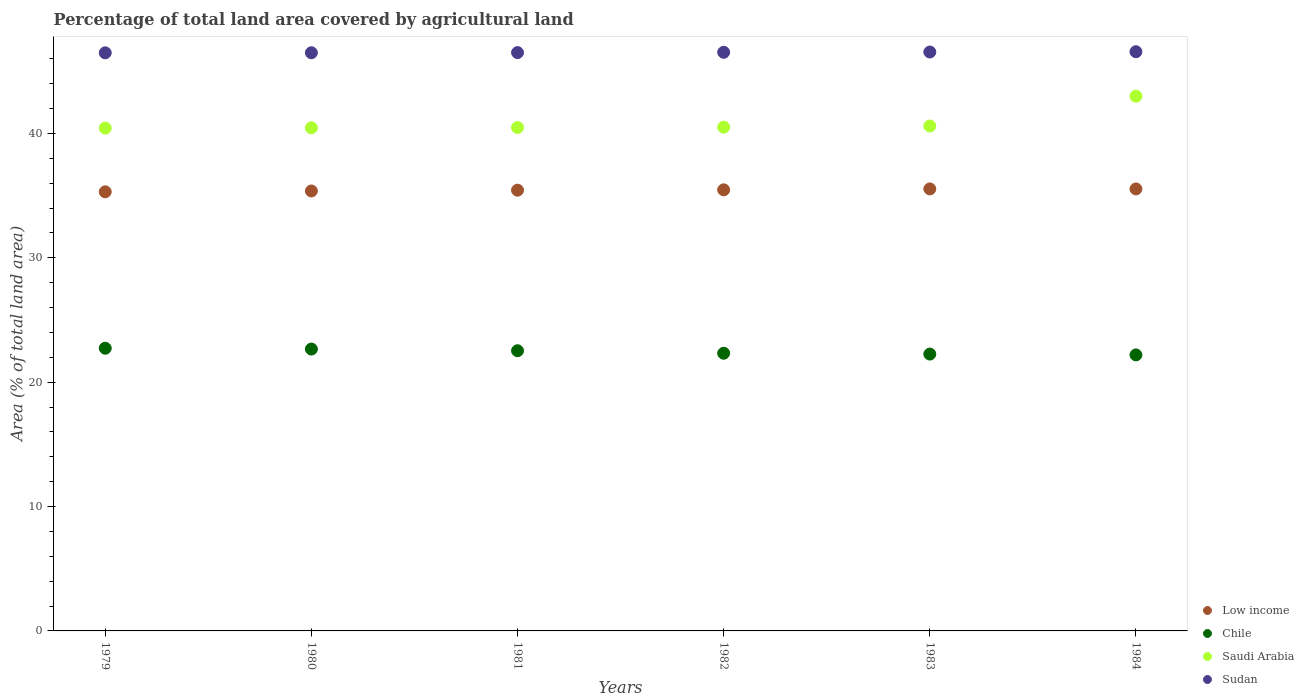How many different coloured dotlines are there?
Provide a succinct answer. 4. What is the percentage of agricultural land in Sudan in 1984?
Your answer should be compact. 46.57. Across all years, what is the maximum percentage of agricultural land in Chile?
Your response must be concise. 22.73. Across all years, what is the minimum percentage of agricultural land in Chile?
Your response must be concise. 22.19. In which year was the percentage of agricultural land in Saudi Arabia minimum?
Your answer should be very brief. 1979. What is the total percentage of agricultural land in Sudan in the graph?
Your answer should be very brief. 279.1. What is the difference between the percentage of agricultural land in Chile in 1980 and that in 1984?
Give a very brief answer. 0.47. What is the difference between the percentage of agricultural land in Sudan in 1979 and the percentage of agricultural land in Saudi Arabia in 1980?
Provide a succinct answer. 6.03. What is the average percentage of agricultural land in Saudi Arabia per year?
Offer a very short reply. 40.91. In the year 1983, what is the difference between the percentage of agricultural land in Chile and percentage of agricultural land in Low income?
Your response must be concise. -13.28. In how many years, is the percentage of agricultural land in Saudi Arabia greater than 42 %?
Give a very brief answer. 1. What is the ratio of the percentage of agricultural land in Low income in 1981 to that in 1982?
Provide a succinct answer. 1. Is the percentage of agricultural land in Saudi Arabia in 1982 less than that in 1984?
Make the answer very short. Yes. Is the difference between the percentage of agricultural land in Chile in 1983 and 1984 greater than the difference between the percentage of agricultural land in Low income in 1983 and 1984?
Your response must be concise. Yes. What is the difference between the highest and the second highest percentage of agricultural land in Saudi Arabia?
Your answer should be very brief. 2.4. What is the difference between the highest and the lowest percentage of agricultural land in Chile?
Make the answer very short. 0.54. Is it the case that in every year, the sum of the percentage of agricultural land in Low income and percentage of agricultural land in Saudi Arabia  is greater than the percentage of agricultural land in Sudan?
Keep it short and to the point. Yes. Does the percentage of agricultural land in Sudan monotonically increase over the years?
Make the answer very short. Yes. Is the percentage of agricultural land in Chile strictly greater than the percentage of agricultural land in Sudan over the years?
Offer a very short reply. No. Is the percentage of agricultural land in Low income strictly less than the percentage of agricultural land in Saudi Arabia over the years?
Make the answer very short. Yes. How many years are there in the graph?
Give a very brief answer. 6. Does the graph contain grids?
Provide a short and direct response. No. How are the legend labels stacked?
Give a very brief answer. Vertical. What is the title of the graph?
Give a very brief answer. Percentage of total land area covered by agricultural land. What is the label or title of the Y-axis?
Offer a terse response. Area (% of total land area). What is the Area (% of total land area) of Low income in 1979?
Provide a short and direct response. 35.31. What is the Area (% of total land area) of Chile in 1979?
Offer a terse response. 22.73. What is the Area (% of total land area) of Saudi Arabia in 1979?
Provide a short and direct response. 40.43. What is the Area (% of total land area) in Sudan in 1979?
Your response must be concise. 46.48. What is the Area (% of total land area) in Low income in 1980?
Make the answer very short. 35.37. What is the Area (% of total land area) of Chile in 1980?
Your response must be concise. 22.66. What is the Area (% of total land area) in Saudi Arabia in 1980?
Offer a terse response. 40.45. What is the Area (% of total land area) in Sudan in 1980?
Give a very brief answer. 46.49. What is the Area (% of total land area) in Low income in 1981?
Provide a succinct answer. 35.44. What is the Area (% of total land area) in Chile in 1981?
Keep it short and to the point. 22.53. What is the Area (% of total land area) in Saudi Arabia in 1981?
Your answer should be very brief. 40.48. What is the Area (% of total land area) in Sudan in 1981?
Your response must be concise. 46.5. What is the Area (% of total land area) of Low income in 1982?
Your answer should be compact. 35.46. What is the Area (% of total land area) of Chile in 1982?
Make the answer very short. 22.33. What is the Area (% of total land area) of Saudi Arabia in 1982?
Provide a short and direct response. 40.5. What is the Area (% of total land area) of Sudan in 1982?
Give a very brief answer. 46.52. What is the Area (% of total land area) of Low income in 1983?
Ensure brevity in your answer.  35.54. What is the Area (% of total land area) in Chile in 1983?
Provide a succinct answer. 22.26. What is the Area (% of total land area) of Saudi Arabia in 1983?
Your answer should be compact. 40.6. What is the Area (% of total land area) in Sudan in 1983?
Provide a short and direct response. 46.54. What is the Area (% of total land area) in Low income in 1984?
Make the answer very short. 35.54. What is the Area (% of total land area) of Chile in 1984?
Offer a very short reply. 22.19. What is the Area (% of total land area) in Saudi Arabia in 1984?
Provide a succinct answer. 42.99. What is the Area (% of total land area) in Sudan in 1984?
Make the answer very short. 46.57. Across all years, what is the maximum Area (% of total land area) of Low income?
Provide a short and direct response. 35.54. Across all years, what is the maximum Area (% of total land area) in Chile?
Make the answer very short. 22.73. Across all years, what is the maximum Area (% of total land area) of Saudi Arabia?
Give a very brief answer. 42.99. Across all years, what is the maximum Area (% of total land area) of Sudan?
Your answer should be compact. 46.57. Across all years, what is the minimum Area (% of total land area) in Low income?
Provide a short and direct response. 35.31. Across all years, what is the minimum Area (% of total land area) in Chile?
Provide a succinct answer. 22.19. Across all years, what is the minimum Area (% of total land area) of Saudi Arabia?
Provide a short and direct response. 40.43. Across all years, what is the minimum Area (% of total land area) in Sudan?
Offer a terse response. 46.48. What is the total Area (% of total land area) of Low income in the graph?
Your answer should be compact. 212.65. What is the total Area (% of total land area) of Chile in the graph?
Keep it short and to the point. 134.69. What is the total Area (% of total land area) in Saudi Arabia in the graph?
Offer a terse response. 245.45. What is the total Area (% of total land area) of Sudan in the graph?
Make the answer very short. 279.1. What is the difference between the Area (% of total land area) of Low income in 1979 and that in 1980?
Your answer should be very brief. -0.07. What is the difference between the Area (% of total land area) in Chile in 1979 and that in 1980?
Give a very brief answer. 0.07. What is the difference between the Area (% of total land area) in Saudi Arabia in 1979 and that in 1980?
Keep it short and to the point. -0.02. What is the difference between the Area (% of total land area) in Sudan in 1979 and that in 1980?
Make the answer very short. -0.01. What is the difference between the Area (% of total land area) of Low income in 1979 and that in 1981?
Provide a succinct answer. -0.13. What is the difference between the Area (% of total land area) of Chile in 1979 and that in 1981?
Offer a very short reply. 0.2. What is the difference between the Area (% of total land area) of Saudi Arabia in 1979 and that in 1981?
Provide a short and direct response. -0.05. What is the difference between the Area (% of total land area) of Sudan in 1979 and that in 1981?
Provide a short and direct response. -0.02. What is the difference between the Area (% of total land area) of Low income in 1979 and that in 1982?
Make the answer very short. -0.16. What is the difference between the Area (% of total land area) in Chile in 1979 and that in 1982?
Give a very brief answer. 0.4. What is the difference between the Area (% of total land area) of Saudi Arabia in 1979 and that in 1982?
Ensure brevity in your answer.  -0.07. What is the difference between the Area (% of total land area) of Sudan in 1979 and that in 1982?
Ensure brevity in your answer.  -0.04. What is the difference between the Area (% of total land area) of Low income in 1979 and that in 1983?
Offer a terse response. -0.23. What is the difference between the Area (% of total land area) in Chile in 1979 and that in 1983?
Provide a short and direct response. 0.47. What is the difference between the Area (% of total land area) in Saudi Arabia in 1979 and that in 1983?
Provide a succinct answer. -0.17. What is the difference between the Area (% of total land area) of Sudan in 1979 and that in 1983?
Offer a very short reply. -0.07. What is the difference between the Area (% of total land area) in Low income in 1979 and that in 1984?
Ensure brevity in your answer.  -0.23. What is the difference between the Area (% of total land area) of Chile in 1979 and that in 1984?
Ensure brevity in your answer.  0.54. What is the difference between the Area (% of total land area) of Saudi Arabia in 1979 and that in 1984?
Give a very brief answer. -2.56. What is the difference between the Area (% of total land area) of Sudan in 1979 and that in 1984?
Give a very brief answer. -0.09. What is the difference between the Area (% of total land area) of Low income in 1980 and that in 1981?
Offer a very short reply. -0.06. What is the difference between the Area (% of total land area) in Chile in 1980 and that in 1981?
Your answer should be very brief. 0.13. What is the difference between the Area (% of total land area) in Saudi Arabia in 1980 and that in 1981?
Your response must be concise. -0.02. What is the difference between the Area (% of total land area) of Sudan in 1980 and that in 1981?
Give a very brief answer. -0.01. What is the difference between the Area (% of total land area) of Low income in 1980 and that in 1982?
Keep it short and to the point. -0.09. What is the difference between the Area (% of total land area) in Chile in 1980 and that in 1982?
Your answer should be compact. 0.34. What is the difference between the Area (% of total land area) of Saudi Arabia in 1980 and that in 1982?
Keep it short and to the point. -0.05. What is the difference between the Area (% of total land area) in Sudan in 1980 and that in 1982?
Give a very brief answer. -0.04. What is the difference between the Area (% of total land area) of Low income in 1980 and that in 1983?
Your response must be concise. -0.17. What is the difference between the Area (% of total land area) in Chile in 1980 and that in 1983?
Offer a very short reply. 0.4. What is the difference between the Area (% of total land area) of Saudi Arabia in 1980 and that in 1983?
Your answer should be compact. -0.14. What is the difference between the Area (% of total land area) in Sudan in 1980 and that in 1983?
Provide a short and direct response. -0.06. What is the difference between the Area (% of total land area) of Low income in 1980 and that in 1984?
Keep it short and to the point. -0.16. What is the difference between the Area (% of total land area) in Chile in 1980 and that in 1984?
Make the answer very short. 0.47. What is the difference between the Area (% of total land area) of Saudi Arabia in 1980 and that in 1984?
Keep it short and to the point. -2.54. What is the difference between the Area (% of total land area) in Sudan in 1980 and that in 1984?
Offer a terse response. -0.08. What is the difference between the Area (% of total land area) of Low income in 1981 and that in 1982?
Make the answer very short. -0.03. What is the difference between the Area (% of total land area) of Chile in 1981 and that in 1982?
Give a very brief answer. 0.2. What is the difference between the Area (% of total land area) of Saudi Arabia in 1981 and that in 1982?
Your response must be concise. -0.03. What is the difference between the Area (% of total land area) of Sudan in 1981 and that in 1982?
Provide a short and direct response. -0.03. What is the difference between the Area (% of total land area) in Low income in 1981 and that in 1983?
Ensure brevity in your answer.  -0.1. What is the difference between the Area (% of total land area) in Chile in 1981 and that in 1983?
Keep it short and to the point. 0.27. What is the difference between the Area (% of total land area) in Saudi Arabia in 1981 and that in 1983?
Provide a succinct answer. -0.12. What is the difference between the Area (% of total land area) in Sudan in 1981 and that in 1983?
Keep it short and to the point. -0.05. What is the difference between the Area (% of total land area) of Low income in 1981 and that in 1984?
Provide a succinct answer. -0.1. What is the difference between the Area (% of total land area) in Chile in 1981 and that in 1984?
Your answer should be very brief. 0.34. What is the difference between the Area (% of total land area) of Saudi Arabia in 1981 and that in 1984?
Your answer should be compact. -2.52. What is the difference between the Area (% of total land area) in Sudan in 1981 and that in 1984?
Keep it short and to the point. -0.07. What is the difference between the Area (% of total land area) in Low income in 1982 and that in 1983?
Offer a very short reply. -0.07. What is the difference between the Area (% of total land area) of Chile in 1982 and that in 1983?
Your answer should be very brief. 0.07. What is the difference between the Area (% of total land area) in Saudi Arabia in 1982 and that in 1983?
Ensure brevity in your answer.  -0.09. What is the difference between the Area (% of total land area) in Sudan in 1982 and that in 1983?
Make the answer very short. -0.02. What is the difference between the Area (% of total land area) of Low income in 1982 and that in 1984?
Offer a terse response. -0.07. What is the difference between the Area (% of total land area) of Chile in 1982 and that in 1984?
Your response must be concise. 0.13. What is the difference between the Area (% of total land area) in Saudi Arabia in 1982 and that in 1984?
Your answer should be compact. -2.49. What is the difference between the Area (% of total land area) of Sudan in 1982 and that in 1984?
Your response must be concise. -0.04. What is the difference between the Area (% of total land area) in Low income in 1983 and that in 1984?
Your answer should be compact. 0. What is the difference between the Area (% of total land area) of Chile in 1983 and that in 1984?
Offer a terse response. 0.07. What is the difference between the Area (% of total land area) in Saudi Arabia in 1983 and that in 1984?
Your answer should be very brief. -2.4. What is the difference between the Area (% of total land area) in Sudan in 1983 and that in 1984?
Offer a very short reply. -0.02. What is the difference between the Area (% of total land area) of Low income in 1979 and the Area (% of total land area) of Chile in 1980?
Ensure brevity in your answer.  12.64. What is the difference between the Area (% of total land area) of Low income in 1979 and the Area (% of total land area) of Saudi Arabia in 1980?
Your response must be concise. -5.15. What is the difference between the Area (% of total land area) in Low income in 1979 and the Area (% of total land area) in Sudan in 1980?
Provide a short and direct response. -11.18. What is the difference between the Area (% of total land area) in Chile in 1979 and the Area (% of total land area) in Saudi Arabia in 1980?
Keep it short and to the point. -17.72. What is the difference between the Area (% of total land area) in Chile in 1979 and the Area (% of total land area) in Sudan in 1980?
Offer a terse response. -23.76. What is the difference between the Area (% of total land area) in Saudi Arabia in 1979 and the Area (% of total land area) in Sudan in 1980?
Give a very brief answer. -6.06. What is the difference between the Area (% of total land area) of Low income in 1979 and the Area (% of total land area) of Chile in 1981?
Your answer should be very brief. 12.78. What is the difference between the Area (% of total land area) in Low income in 1979 and the Area (% of total land area) in Saudi Arabia in 1981?
Provide a succinct answer. -5.17. What is the difference between the Area (% of total land area) of Low income in 1979 and the Area (% of total land area) of Sudan in 1981?
Offer a terse response. -11.19. What is the difference between the Area (% of total land area) in Chile in 1979 and the Area (% of total land area) in Saudi Arabia in 1981?
Your answer should be compact. -17.75. What is the difference between the Area (% of total land area) of Chile in 1979 and the Area (% of total land area) of Sudan in 1981?
Your response must be concise. -23.77. What is the difference between the Area (% of total land area) of Saudi Arabia in 1979 and the Area (% of total land area) of Sudan in 1981?
Your answer should be compact. -6.07. What is the difference between the Area (% of total land area) in Low income in 1979 and the Area (% of total land area) in Chile in 1982?
Ensure brevity in your answer.  12.98. What is the difference between the Area (% of total land area) of Low income in 1979 and the Area (% of total land area) of Saudi Arabia in 1982?
Your answer should be very brief. -5.2. What is the difference between the Area (% of total land area) in Low income in 1979 and the Area (% of total land area) in Sudan in 1982?
Offer a very short reply. -11.22. What is the difference between the Area (% of total land area) of Chile in 1979 and the Area (% of total land area) of Saudi Arabia in 1982?
Your answer should be very brief. -17.77. What is the difference between the Area (% of total land area) of Chile in 1979 and the Area (% of total land area) of Sudan in 1982?
Offer a terse response. -23.79. What is the difference between the Area (% of total land area) of Saudi Arabia in 1979 and the Area (% of total land area) of Sudan in 1982?
Your answer should be compact. -6.09. What is the difference between the Area (% of total land area) of Low income in 1979 and the Area (% of total land area) of Chile in 1983?
Provide a succinct answer. 13.05. What is the difference between the Area (% of total land area) in Low income in 1979 and the Area (% of total land area) in Saudi Arabia in 1983?
Your answer should be compact. -5.29. What is the difference between the Area (% of total land area) of Low income in 1979 and the Area (% of total land area) of Sudan in 1983?
Your answer should be very brief. -11.24. What is the difference between the Area (% of total land area) in Chile in 1979 and the Area (% of total land area) in Saudi Arabia in 1983?
Provide a short and direct response. -17.87. What is the difference between the Area (% of total land area) in Chile in 1979 and the Area (% of total land area) in Sudan in 1983?
Provide a succinct answer. -23.82. What is the difference between the Area (% of total land area) in Saudi Arabia in 1979 and the Area (% of total land area) in Sudan in 1983?
Keep it short and to the point. -6.12. What is the difference between the Area (% of total land area) in Low income in 1979 and the Area (% of total land area) in Chile in 1984?
Offer a terse response. 13.11. What is the difference between the Area (% of total land area) of Low income in 1979 and the Area (% of total land area) of Saudi Arabia in 1984?
Your answer should be compact. -7.69. What is the difference between the Area (% of total land area) in Low income in 1979 and the Area (% of total land area) in Sudan in 1984?
Keep it short and to the point. -11.26. What is the difference between the Area (% of total land area) in Chile in 1979 and the Area (% of total land area) in Saudi Arabia in 1984?
Ensure brevity in your answer.  -20.26. What is the difference between the Area (% of total land area) in Chile in 1979 and the Area (% of total land area) in Sudan in 1984?
Make the answer very short. -23.84. What is the difference between the Area (% of total land area) of Saudi Arabia in 1979 and the Area (% of total land area) of Sudan in 1984?
Make the answer very short. -6.14. What is the difference between the Area (% of total land area) in Low income in 1980 and the Area (% of total land area) in Chile in 1981?
Provide a succinct answer. 12.85. What is the difference between the Area (% of total land area) in Low income in 1980 and the Area (% of total land area) in Saudi Arabia in 1981?
Your answer should be compact. -5.1. What is the difference between the Area (% of total land area) in Low income in 1980 and the Area (% of total land area) in Sudan in 1981?
Offer a very short reply. -11.13. What is the difference between the Area (% of total land area) in Chile in 1980 and the Area (% of total land area) in Saudi Arabia in 1981?
Your response must be concise. -17.81. What is the difference between the Area (% of total land area) in Chile in 1980 and the Area (% of total land area) in Sudan in 1981?
Keep it short and to the point. -23.84. What is the difference between the Area (% of total land area) in Saudi Arabia in 1980 and the Area (% of total land area) in Sudan in 1981?
Keep it short and to the point. -6.04. What is the difference between the Area (% of total land area) in Low income in 1980 and the Area (% of total land area) in Chile in 1982?
Provide a short and direct response. 13.05. What is the difference between the Area (% of total land area) in Low income in 1980 and the Area (% of total land area) in Saudi Arabia in 1982?
Provide a short and direct response. -5.13. What is the difference between the Area (% of total land area) of Low income in 1980 and the Area (% of total land area) of Sudan in 1982?
Provide a succinct answer. -11.15. What is the difference between the Area (% of total land area) of Chile in 1980 and the Area (% of total land area) of Saudi Arabia in 1982?
Offer a terse response. -17.84. What is the difference between the Area (% of total land area) in Chile in 1980 and the Area (% of total land area) in Sudan in 1982?
Your answer should be very brief. -23.86. What is the difference between the Area (% of total land area) in Saudi Arabia in 1980 and the Area (% of total land area) in Sudan in 1982?
Give a very brief answer. -6.07. What is the difference between the Area (% of total land area) of Low income in 1980 and the Area (% of total land area) of Chile in 1983?
Provide a short and direct response. 13.11. What is the difference between the Area (% of total land area) of Low income in 1980 and the Area (% of total land area) of Saudi Arabia in 1983?
Provide a succinct answer. -5.22. What is the difference between the Area (% of total land area) in Low income in 1980 and the Area (% of total land area) in Sudan in 1983?
Your answer should be very brief. -11.17. What is the difference between the Area (% of total land area) in Chile in 1980 and the Area (% of total land area) in Saudi Arabia in 1983?
Your answer should be compact. -17.93. What is the difference between the Area (% of total land area) in Chile in 1980 and the Area (% of total land area) in Sudan in 1983?
Ensure brevity in your answer.  -23.88. What is the difference between the Area (% of total land area) of Saudi Arabia in 1980 and the Area (% of total land area) of Sudan in 1983?
Provide a succinct answer. -6.09. What is the difference between the Area (% of total land area) of Low income in 1980 and the Area (% of total land area) of Chile in 1984?
Make the answer very short. 13.18. What is the difference between the Area (% of total land area) in Low income in 1980 and the Area (% of total land area) in Saudi Arabia in 1984?
Provide a succinct answer. -7.62. What is the difference between the Area (% of total land area) of Low income in 1980 and the Area (% of total land area) of Sudan in 1984?
Keep it short and to the point. -11.2. What is the difference between the Area (% of total land area) in Chile in 1980 and the Area (% of total land area) in Saudi Arabia in 1984?
Your response must be concise. -20.33. What is the difference between the Area (% of total land area) of Chile in 1980 and the Area (% of total land area) of Sudan in 1984?
Provide a succinct answer. -23.91. What is the difference between the Area (% of total land area) in Saudi Arabia in 1980 and the Area (% of total land area) in Sudan in 1984?
Make the answer very short. -6.11. What is the difference between the Area (% of total land area) of Low income in 1981 and the Area (% of total land area) of Chile in 1982?
Your response must be concise. 13.11. What is the difference between the Area (% of total land area) in Low income in 1981 and the Area (% of total land area) in Saudi Arabia in 1982?
Your answer should be compact. -5.07. What is the difference between the Area (% of total land area) in Low income in 1981 and the Area (% of total land area) in Sudan in 1982?
Provide a succinct answer. -11.09. What is the difference between the Area (% of total land area) in Chile in 1981 and the Area (% of total land area) in Saudi Arabia in 1982?
Provide a short and direct response. -17.98. What is the difference between the Area (% of total land area) of Chile in 1981 and the Area (% of total land area) of Sudan in 1982?
Your answer should be very brief. -24. What is the difference between the Area (% of total land area) in Saudi Arabia in 1981 and the Area (% of total land area) in Sudan in 1982?
Ensure brevity in your answer.  -6.05. What is the difference between the Area (% of total land area) of Low income in 1981 and the Area (% of total land area) of Chile in 1983?
Ensure brevity in your answer.  13.18. What is the difference between the Area (% of total land area) of Low income in 1981 and the Area (% of total land area) of Saudi Arabia in 1983?
Keep it short and to the point. -5.16. What is the difference between the Area (% of total land area) of Low income in 1981 and the Area (% of total land area) of Sudan in 1983?
Keep it short and to the point. -11.11. What is the difference between the Area (% of total land area) of Chile in 1981 and the Area (% of total land area) of Saudi Arabia in 1983?
Provide a short and direct response. -18.07. What is the difference between the Area (% of total land area) of Chile in 1981 and the Area (% of total land area) of Sudan in 1983?
Your answer should be very brief. -24.02. What is the difference between the Area (% of total land area) of Saudi Arabia in 1981 and the Area (% of total land area) of Sudan in 1983?
Your answer should be very brief. -6.07. What is the difference between the Area (% of total land area) of Low income in 1981 and the Area (% of total land area) of Chile in 1984?
Provide a short and direct response. 13.24. What is the difference between the Area (% of total land area) of Low income in 1981 and the Area (% of total land area) of Saudi Arabia in 1984?
Make the answer very short. -7.56. What is the difference between the Area (% of total land area) in Low income in 1981 and the Area (% of total land area) in Sudan in 1984?
Keep it short and to the point. -11.13. What is the difference between the Area (% of total land area) in Chile in 1981 and the Area (% of total land area) in Saudi Arabia in 1984?
Your response must be concise. -20.47. What is the difference between the Area (% of total land area) in Chile in 1981 and the Area (% of total land area) in Sudan in 1984?
Offer a terse response. -24.04. What is the difference between the Area (% of total land area) of Saudi Arabia in 1981 and the Area (% of total land area) of Sudan in 1984?
Ensure brevity in your answer.  -6.09. What is the difference between the Area (% of total land area) in Low income in 1982 and the Area (% of total land area) in Chile in 1983?
Offer a very short reply. 13.21. What is the difference between the Area (% of total land area) in Low income in 1982 and the Area (% of total land area) in Saudi Arabia in 1983?
Offer a terse response. -5.13. What is the difference between the Area (% of total land area) of Low income in 1982 and the Area (% of total land area) of Sudan in 1983?
Provide a succinct answer. -11.08. What is the difference between the Area (% of total land area) of Chile in 1982 and the Area (% of total land area) of Saudi Arabia in 1983?
Your answer should be compact. -18.27. What is the difference between the Area (% of total land area) in Chile in 1982 and the Area (% of total land area) in Sudan in 1983?
Provide a short and direct response. -24.22. What is the difference between the Area (% of total land area) in Saudi Arabia in 1982 and the Area (% of total land area) in Sudan in 1983?
Make the answer very short. -6.04. What is the difference between the Area (% of total land area) of Low income in 1982 and the Area (% of total land area) of Chile in 1984?
Your response must be concise. 13.27. What is the difference between the Area (% of total land area) in Low income in 1982 and the Area (% of total land area) in Saudi Arabia in 1984?
Give a very brief answer. -7.53. What is the difference between the Area (% of total land area) in Low income in 1982 and the Area (% of total land area) in Sudan in 1984?
Provide a short and direct response. -11.1. What is the difference between the Area (% of total land area) of Chile in 1982 and the Area (% of total land area) of Saudi Arabia in 1984?
Offer a terse response. -20.67. What is the difference between the Area (% of total land area) in Chile in 1982 and the Area (% of total land area) in Sudan in 1984?
Provide a succinct answer. -24.24. What is the difference between the Area (% of total land area) in Saudi Arabia in 1982 and the Area (% of total land area) in Sudan in 1984?
Provide a short and direct response. -6.07. What is the difference between the Area (% of total land area) of Low income in 1983 and the Area (% of total land area) of Chile in 1984?
Your response must be concise. 13.35. What is the difference between the Area (% of total land area) of Low income in 1983 and the Area (% of total land area) of Saudi Arabia in 1984?
Offer a terse response. -7.45. What is the difference between the Area (% of total land area) in Low income in 1983 and the Area (% of total land area) in Sudan in 1984?
Ensure brevity in your answer.  -11.03. What is the difference between the Area (% of total land area) in Chile in 1983 and the Area (% of total land area) in Saudi Arabia in 1984?
Provide a short and direct response. -20.73. What is the difference between the Area (% of total land area) in Chile in 1983 and the Area (% of total land area) in Sudan in 1984?
Provide a short and direct response. -24.31. What is the difference between the Area (% of total land area) of Saudi Arabia in 1983 and the Area (% of total land area) of Sudan in 1984?
Provide a succinct answer. -5.97. What is the average Area (% of total land area) in Low income per year?
Give a very brief answer. 35.44. What is the average Area (% of total land area) of Chile per year?
Ensure brevity in your answer.  22.45. What is the average Area (% of total land area) in Saudi Arabia per year?
Provide a short and direct response. 40.91. What is the average Area (% of total land area) in Sudan per year?
Your answer should be very brief. 46.52. In the year 1979, what is the difference between the Area (% of total land area) in Low income and Area (% of total land area) in Chile?
Provide a succinct answer. 12.58. In the year 1979, what is the difference between the Area (% of total land area) of Low income and Area (% of total land area) of Saudi Arabia?
Offer a very short reply. -5.12. In the year 1979, what is the difference between the Area (% of total land area) in Low income and Area (% of total land area) in Sudan?
Your answer should be compact. -11.17. In the year 1979, what is the difference between the Area (% of total land area) in Chile and Area (% of total land area) in Saudi Arabia?
Ensure brevity in your answer.  -17.7. In the year 1979, what is the difference between the Area (% of total land area) of Chile and Area (% of total land area) of Sudan?
Give a very brief answer. -23.75. In the year 1979, what is the difference between the Area (% of total land area) of Saudi Arabia and Area (% of total land area) of Sudan?
Make the answer very short. -6.05. In the year 1980, what is the difference between the Area (% of total land area) of Low income and Area (% of total land area) of Chile?
Provide a short and direct response. 12.71. In the year 1980, what is the difference between the Area (% of total land area) of Low income and Area (% of total land area) of Saudi Arabia?
Give a very brief answer. -5.08. In the year 1980, what is the difference between the Area (% of total land area) in Low income and Area (% of total land area) in Sudan?
Your answer should be compact. -11.11. In the year 1980, what is the difference between the Area (% of total land area) in Chile and Area (% of total land area) in Saudi Arabia?
Provide a succinct answer. -17.79. In the year 1980, what is the difference between the Area (% of total land area) in Chile and Area (% of total land area) in Sudan?
Give a very brief answer. -23.82. In the year 1980, what is the difference between the Area (% of total land area) in Saudi Arabia and Area (% of total land area) in Sudan?
Make the answer very short. -6.03. In the year 1981, what is the difference between the Area (% of total land area) of Low income and Area (% of total land area) of Chile?
Offer a terse response. 12.91. In the year 1981, what is the difference between the Area (% of total land area) of Low income and Area (% of total land area) of Saudi Arabia?
Keep it short and to the point. -5.04. In the year 1981, what is the difference between the Area (% of total land area) of Low income and Area (% of total land area) of Sudan?
Your answer should be compact. -11.06. In the year 1981, what is the difference between the Area (% of total land area) of Chile and Area (% of total land area) of Saudi Arabia?
Provide a succinct answer. -17.95. In the year 1981, what is the difference between the Area (% of total land area) of Chile and Area (% of total land area) of Sudan?
Ensure brevity in your answer.  -23.97. In the year 1981, what is the difference between the Area (% of total land area) of Saudi Arabia and Area (% of total land area) of Sudan?
Your answer should be very brief. -6.02. In the year 1982, what is the difference between the Area (% of total land area) of Low income and Area (% of total land area) of Chile?
Your response must be concise. 13.14. In the year 1982, what is the difference between the Area (% of total land area) of Low income and Area (% of total land area) of Saudi Arabia?
Make the answer very short. -5.04. In the year 1982, what is the difference between the Area (% of total land area) of Low income and Area (% of total land area) of Sudan?
Your answer should be compact. -11.06. In the year 1982, what is the difference between the Area (% of total land area) in Chile and Area (% of total land area) in Saudi Arabia?
Your answer should be compact. -18.18. In the year 1982, what is the difference between the Area (% of total land area) in Chile and Area (% of total land area) in Sudan?
Give a very brief answer. -24.2. In the year 1982, what is the difference between the Area (% of total land area) of Saudi Arabia and Area (% of total land area) of Sudan?
Offer a very short reply. -6.02. In the year 1983, what is the difference between the Area (% of total land area) in Low income and Area (% of total land area) in Chile?
Give a very brief answer. 13.28. In the year 1983, what is the difference between the Area (% of total land area) in Low income and Area (% of total land area) in Saudi Arabia?
Ensure brevity in your answer.  -5.06. In the year 1983, what is the difference between the Area (% of total land area) in Low income and Area (% of total land area) in Sudan?
Give a very brief answer. -11.01. In the year 1983, what is the difference between the Area (% of total land area) in Chile and Area (% of total land area) in Saudi Arabia?
Give a very brief answer. -18.34. In the year 1983, what is the difference between the Area (% of total land area) of Chile and Area (% of total land area) of Sudan?
Provide a short and direct response. -24.29. In the year 1983, what is the difference between the Area (% of total land area) in Saudi Arabia and Area (% of total land area) in Sudan?
Your answer should be very brief. -5.95. In the year 1984, what is the difference between the Area (% of total land area) of Low income and Area (% of total land area) of Chile?
Ensure brevity in your answer.  13.34. In the year 1984, what is the difference between the Area (% of total land area) of Low income and Area (% of total land area) of Saudi Arabia?
Give a very brief answer. -7.46. In the year 1984, what is the difference between the Area (% of total land area) of Low income and Area (% of total land area) of Sudan?
Give a very brief answer. -11.03. In the year 1984, what is the difference between the Area (% of total land area) of Chile and Area (% of total land area) of Saudi Arabia?
Your answer should be compact. -20.8. In the year 1984, what is the difference between the Area (% of total land area) of Chile and Area (% of total land area) of Sudan?
Your response must be concise. -24.38. In the year 1984, what is the difference between the Area (% of total land area) of Saudi Arabia and Area (% of total land area) of Sudan?
Offer a terse response. -3.57. What is the ratio of the Area (% of total land area) in Low income in 1979 to that in 1980?
Give a very brief answer. 1. What is the ratio of the Area (% of total land area) of Chile in 1979 to that in 1980?
Keep it short and to the point. 1. What is the ratio of the Area (% of total land area) of Saudi Arabia in 1979 to that in 1980?
Ensure brevity in your answer.  1. What is the ratio of the Area (% of total land area) in Low income in 1979 to that in 1981?
Your answer should be very brief. 1. What is the ratio of the Area (% of total land area) of Saudi Arabia in 1979 to that in 1981?
Your response must be concise. 1. What is the ratio of the Area (% of total land area) in Low income in 1979 to that in 1982?
Give a very brief answer. 1. What is the ratio of the Area (% of total land area) in Chile in 1979 to that in 1982?
Ensure brevity in your answer.  1.02. What is the ratio of the Area (% of total land area) in Saudi Arabia in 1979 to that in 1982?
Offer a very short reply. 1. What is the ratio of the Area (% of total land area) in Sudan in 1979 to that in 1982?
Provide a succinct answer. 1. What is the ratio of the Area (% of total land area) in Low income in 1979 to that in 1983?
Your answer should be very brief. 0.99. What is the ratio of the Area (% of total land area) of Chile in 1979 to that in 1983?
Ensure brevity in your answer.  1.02. What is the ratio of the Area (% of total land area) in Sudan in 1979 to that in 1983?
Your answer should be very brief. 1. What is the ratio of the Area (% of total land area) in Chile in 1979 to that in 1984?
Offer a very short reply. 1.02. What is the ratio of the Area (% of total land area) in Saudi Arabia in 1979 to that in 1984?
Offer a very short reply. 0.94. What is the ratio of the Area (% of total land area) in Sudan in 1979 to that in 1984?
Provide a succinct answer. 1. What is the ratio of the Area (% of total land area) of Low income in 1980 to that in 1981?
Give a very brief answer. 1. What is the ratio of the Area (% of total land area) of Sudan in 1980 to that in 1981?
Offer a terse response. 1. What is the ratio of the Area (% of total land area) in Chile in 1980 to that in 1982?
Make the answer very short. 1.02. What is the ratio of the Area (% of total land area) of Saudi Arabia in 1980 to that in 1982?
Provide a succinct answer. 1. What is the ratio of the Area (% of total land area) in Low income in 1980 to that in 1983?
Provide a short and direct response. 1. What is the ratio of the Area (% of total land area) in Chile in 1980 to that in 1983?
Your response must be concise. 1.02. What is the ratio of the Area (% of total land area) of Chile in 1980 to that in 1984?
Ensure brevity in your answer.  1.02. What is the ratio of the Area (% of total land area) in Saudi Arabia in 1980 to that in 1984?
Offer a very short reply. 0.94. What is the ratio of the Area (% of total land area) of Low income in 1981 to that in 1982?
Provide a short and direct response. 1. What is the ratio of the Area (% of total land area) in Chile in 1981 to that in 1982?
Your response must be concise. 1.01. What is the ratio of the Area (% of total land area) of Saudi Arabia in 1981 to that in 1982?
Provide a succinct answer. 1. What is the ratio of the Area (% of total land area) of Sudan in 1981 to that in 1982?
Provide a succinct answer. 1. What is the ratio of the Area (% of total land area) of Low income in 1981 to that in 1983?
Your answer should be very brief. 1. What is the ratio of the Area (% of total land area) in Chile in 1981 to that in 1983?
Offer a very short reply. 1.01. What is the ratio of the Area (% of total land area) of Saudi Arabia in 1981 to that in 1983?
Your response must be concise. 1. What is the ratio of the Area (% of total land area) in Low income in 1981 to that in 1984?
Your answer should be very brief. 1. What is the ratio of the Area (% of total land area) of Chile in 1981 to that in 1984?
Offer a terse response. 1.02. What is the ratio of the Area (% of total land area) of Saudi Arabia in 1981 to that in 1984?
Your response must be concise. 0.94. What is the ratio of the Area (% of total land area) of Saudi Arabia in 1982 to that in 1983?
Keep it short and to the point. 1. What is the ratio of the Area (% of total land area) in Sudan in 1982 to that in 1983?
Give a very brief answer. 1. What is the ratio of the Area (% of total land area) in Low income in 1982 to that in 1984?
Offer a terse response. 1. What is the ratio of the Area (% of total land area) in Saudi Arabia in 1982 to that in 1984?
Give a very brief answer. 0.94. What is the ratio of the Area (% of total land area) in Low income in 1983 to that in 1984?
Your answer should be compact. 1. What is the ratio of the Area (% of total land area) of Saudi Arabia in 1983 to that in 1984?
Your answer should be very brief. 0.94. What is the ratio of the Area (% of total land area) in Sudan in 1983 to that in 1984?
Offer a terse response. 1. What is the difference between the highest and the second highest Area (% of total land area) in Low income?
Ensure brevity in your answer.  0. What is the difference between the highest and the second highest Area (% of total land area) of Chile?
Your answer should be compact. 0.07. What is the difference between the highest and the second highest Area (% of total land area) of Saudi Arabia?
Your answer should be compact. 2.4. What is the difference between the highest and the second highest Area (% of total land area) of Sudan?
Your answer should be very brief. 0.02. What is the difference between the highest and the lowest Area (% of total land area) in Low income?
Ensure brevity in your answer.  0.23. What is the difference between the highest and the lowest Area (% of total land area) in Chile?
Your response must be concise. 0.54. What is the difference between the highest and the lowest Area (% of total land area) of Saudi Arabia?
Keep it short and to the point. 2.56. What is the difference between the highest and the lowest Area (% of total land area) in Sudan?
Your response must be concise. 0.09. 